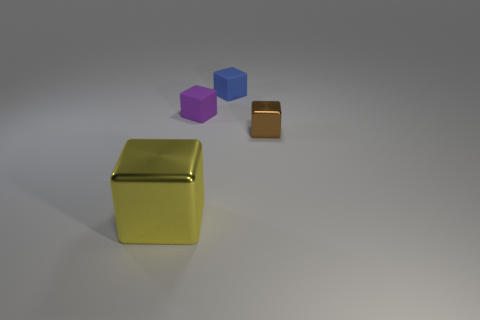Subtract 1 cubes. How many cubes are left? 3 Add 4 tiny brown blocks. How many objects exist? 8 Subtract 1 brown cubes. How many objects are left? 3 Subtract all large yellow rubber balls. Subtract all small blue blocks. How many objects are left? 3 Add 1 brown metal blocks. How many brown metal blocks are left? 2 Add 3 large shiny objects. How many large shiny objects exist? 4 